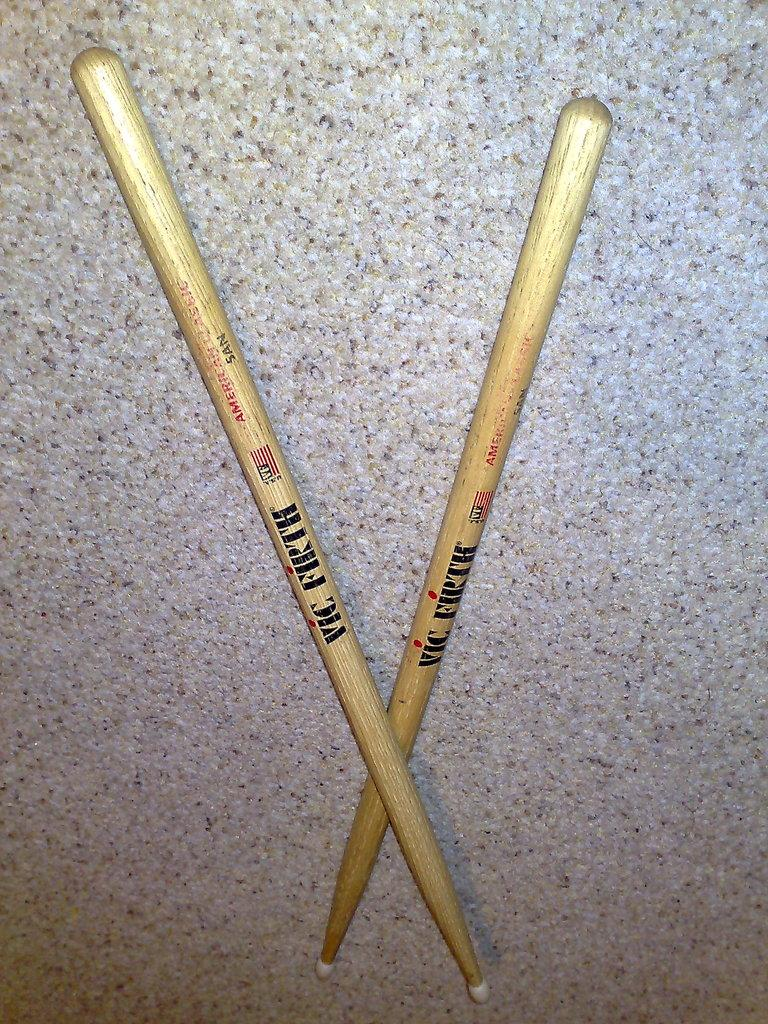What objects can be seen in the image? There are two sticks in the image. How are the sticks arranged? The sticks are arranged in a cross shape. Where are the sticks located? The sticks are on the ground. What type of chin can be seen supporting the wall in the image? There is no chin or wall present in the image; it only features two sticks arranged in a cross shape on the ground. 